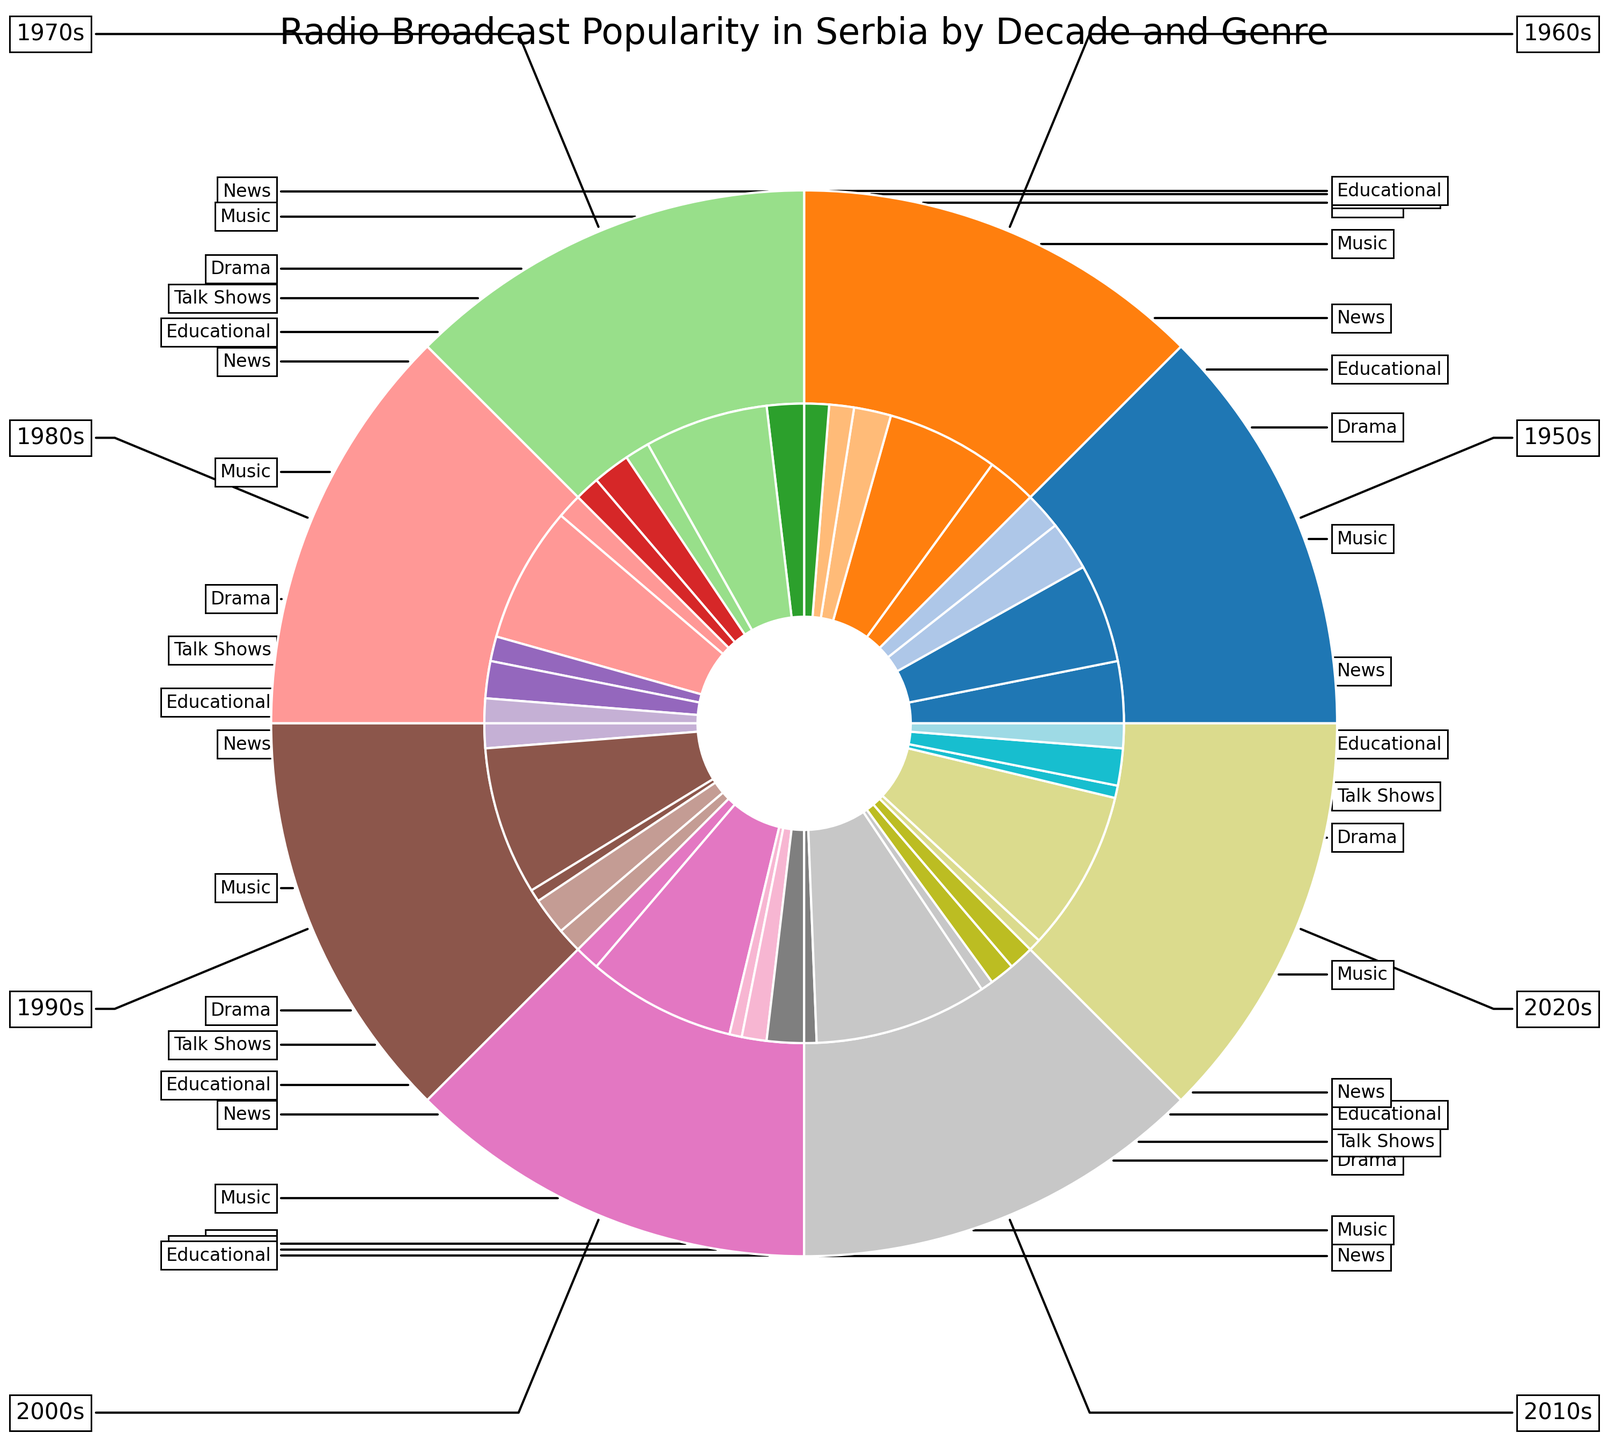Which decade had the highest overall radio broadcast popularity? By examining the outer ring of the nested pie chart, the 2010s have the largest segment indicating the highest overall popularity.
Answer: 2010s In the 1950s, which genre was the second most popular? Referring to the inner ring within the 1950s segment, News is the second-largest slice after Music.
Answer: News How does the popularity of Music in the 1990s compare to the 2000s? Looking at the inner segments for these decades, Music's slice is equal in size for both the 1990s and the 2000s, indicating equal popularity.
Answer: Equal What is the sum of the popularity percentages for Talk Shows from the 1950s to the 2020s? Summing up the percentages of Talk Shows from each decade: 0 (1950s) + 10 (1960s) + 15 (1970s) + 15 (1980s) + 15 (1990s) + 10 (2000s) + 10 (2010s) + 15 (2020s) = 90%.
Answer: 90% Which genre had the lowest popularity in the 1950s? Within the 1950s segment, Educational has the smallest slice among all genres.
Answer: Educational Order the decades by the popularity of Educational content from highest to lowest. Checking the inner segments for Educational content: 1950s (15), 1960s (10), 1970s (10), 1980s (10), 1990s (10), 2000s (15), 2010s (10), 2020s (10), we get 1950s = 15, 2000s = 15, others = 10.
Answer: 1950s, 2000s, 1960s, 1970s, 1980s, 1990s, 2010s, 2020s In which decade did Drama experience the biggest drop in popularity compared to the previous decade? Comparing the Drama segments in each decade, the drop from 1950s (20) to 1960s (15), 1960s (15) to 1970s (10), 1970s (10) to 1980s (10), 1980s (10) to 1990s (5), 1990s (5) to 2000s (5), 2000s (5) to 2010s (5), 2010s (5) to 2020s (5), the biggest drop is from 1950s to 1960s (20 to 15).
Answer: 1960s Is the popularity of News increasing or decreasing over the decades? Observing the inner segments for News: 1950s (25), 1960s (20), 1970s (15), 1980s (10), 1990s (10), 2000s (10), 2010s (5), 2020s (5), we see a clear decreasing trend.
Answer: Decreasing 